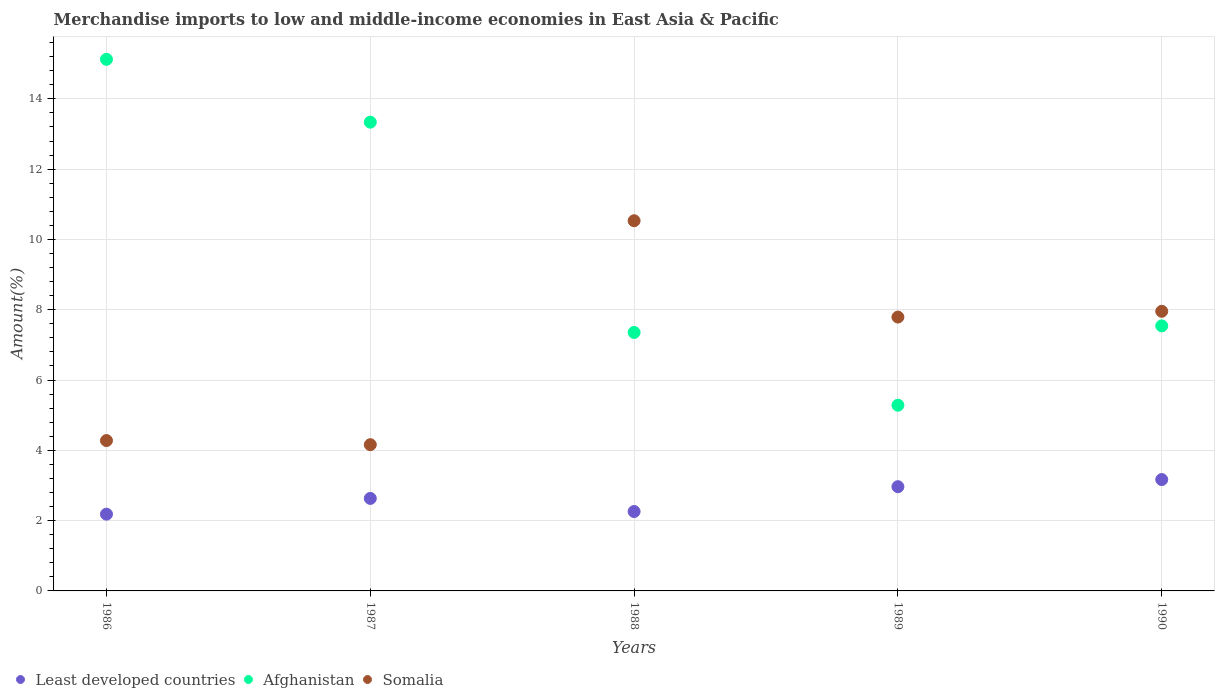Is the number of dotlines equal to the number of legend labels?
Provide a succinct answer. Yes. What is the percentage of amount earned from merchandise imports in Least developed countries in 1987?
Ensure brevity in your answer.  2.63. Across all years, what is the maximum percentage of amount earned from merchandise imports in Somalia?
Offer a very short reply. 10.53. Across all years, what is the minimum percentage of amount earned from merchandise imports in Afghanistan?
Offer a very short reply. 5.28. In which year was the percentage of amount earned from merchandise imports in Somalia maximum?
Give a very brief answer. 1988. What is the total percentage of amount earned from merchandise imports in Least developed countries in the graph?
Your response must be concise. 13.21. What is the difference between the percentage of amount earned from merchandise imports in Somalia in 1986 and that in 1988?
Your answer should be very brief. -6.25. What is the difference between the percentage of amount earned from merchandise imports in Least developed countries in 1986 and the percentage of amount earned from merchandise imports in Somalia in 1990?
Provide a short and direct response. -5.77. What is the average percentage of amount earned from merchandise imports in Somalia per year?
Provide a short and direct response. 6.94. In the year 1989, what is the difference between the percentage of amount earned from merchandise imports in Somalia and percentage of amount earned from merchandise imports in Afghanistan?
Provide a succinct answer. 2.51. What is the ratio of the percentage of amount earned from merchandise imports in Afghanistan in 1986 to that in 1987?
Make the answer very short. 1.13. Is the percentage of amount earned from merchandise imports in Least developed countries in 1989 less than that in 1990?
Provide a short and direct response. Yes. What is the difference between the highest and the second highest percentage of amount earned from merchandise imports in Least developed countries?
Ensure brevity in your answer.  0.2. What is the difference between the highest and the lowest percentage of amount earned from merchandise imports in Least developed countries?
Your answer should be very brief. 0.98. Is the sum of the percentage of amount earned from merchandise imports in Least developed countries in 1989 and 1990 greater than the maximum percentage of amount earned from merchandise imports in Somalia across all years?
Make the answer very short. No. Is it the case that in every year, the sum of the percentage of amount earned from merchandise imports in Least developed countries and percentage of amount earned from merchandise imports in Afghanistan  is greater than the percentage of amount earned from merchandise imports in Somalia?
Your answer should be compact. No. Is the percentage of amount earned from merchandise imports in Afghanistan strictly greater than the percentage of amount earned from merchandise imports in Somalia over the years?
Ensure brevity in your answer.  No. How many dotlines are there?
Your answer should be very brief. 3. What is the difference between two consecutive major ticks on the Y-axis?
Provide a succinct answer. 2. How are the legend labels stacked?
Provide a short and direct response. Horizontal. What is the title of the graph?
Give a very brief answer. Merchandise imports to low and middle-income economies in East Asia & Pacific. Does "Benin" appear as one of the legend labels in the graph?
Give a very brief answer. No. What is the label or title of the Y-axis?
Give a very brief answer. Amount(%). What is the Amount(%) in Least developed countries in 1986?
Make the answer very short. 2.18. What is the Amount(%) in Afghanistan in 1986?
Provide a short and direct response. 15.12. What is the Amount(%) of Somalia in 1986?
Your answer should be compact. 4.28. What is the Amount(%) of Least developed countries in 1987?
Your answer should be compact. 2.63. What is the Amount(%) of Afghanistan in 1987?
Provide a succinct answer. 13.34. What is the Amount(%) of Somalia in 1987?
Your answer should be very brief. 4.16. What is the Amount(%) of Least developed countries in 1988?
Keep it short and to the point. 2.26. What is the Amount(%) of Afghanistan in 1988?
Offer a terse response. 7.35. What is the Amount(%) of Somalia in 1988?
Your answer should be compact. 10.53. What is the Amount(%) of Least developed countries in 1989?
Make the answer very short. 2.97. What is the Amount(%) of Afghanistan in 1989?
Your answer should be very brief. 5.28. What is the Amount(%) in Somalia in 1989?
Give a very brief answer. 7.79. What is the Amount(%) of Least developed countries in 1990?
Your answer should be compact. 3.17. What is the Amount(%) of Afghanistan in 1990?
Provide a short and direct response. 7.54. What is the Amount(%) in Somalia in 1990?
Your response must be concise. 7.96. Across all years, what is the maximum Amount(%) in Least developed countries?
Your answer should be very brief. 3.17. Across all years, what is the maximum Amount(%) of Afghanistan?
Give a very brief answer. 15.12. Across all years, what is the maximum Amount(%) in Somalia?
Make the answer very short. 10.53. Across all years, what is the minimum Amount(%) of Least developed countries?
Make the answer very short. 2.18. Across all years, what is the minimum Amount(%) in Afghanistan?
Give a very brief answer. 5.28. Across all years, what is the minimum Amount(%) in Somalia?
Keep it short and to the point. 4.16. What is the total Amount(%) of Least developed countries in the graph?
Provide a short and direct response. 13.21. What is the total Amount(%) of Afghanistan in the graph?
Your answer should be very brief. 48.64. What is the total Amount(%) in Somalia in the graph?
Provide a short and direct response. 34.72. What is the difference between the Amount(%) of Least developed countries in 1986 and that in 1987?
Provide a short and direct response. -0.45. What is the difference between the Amount(%) in Afghanistan in 1986 and that in 1987?
Give a very brief answer. 1.79. What is the difference between the Amount(%) in Somalia in 1986 and that in 1987?
Offer a very short reply. 0.12. What is the difference between the Amount(%) of Least developed countries in 1986 and that in 1988?
Keep it short and to the point. -0.08. What is the difference between the Amount(%) of Afghanistan in 1986 and that in 1988?
Offer a terse response. 7.77. What is the difference between the Amount(%) in Somalia in 1986 and that in 1988?
Keep it short and to the point. -6.25. What is the difference between the Amount(%) of Least developed countries in 1986 and that in 1989?
Provide a succinct answer. -0.78. What is the difference between the Amount(%) in Afghanistan in 1986 and that in 1989?
Provide a short and direct response. 9.84. What is the difference between the Amount(%) in Somalia in 1986 and that in 1989?
Ensure brevity in your answer.  -3.51. What is the difference between the Amount(%) of Least developed countries in 1986 and that in 1990?
Your answer should be very brief. -0.98. What is the difference between the Amount(%) of Afghanistan in 1986 and that in 1990?
Ensure brevity in your answer.  7.58. What is the difference between the Amount(%) in Somalia in 1986 and that in 1990?
Keep it short and to the point. -3.68. What is the difference between the Amount(%) in Least developed countries in 1987 and that in 1988?
Provide a succinct answer. 0.37. What is the difference between the Amount(%) of Afghanistan in 1987 and that in 1988?
Provide a succinct answer. 5.98. What is the difference between the Amount(%) of Somalia in 1987 and that in 1988?
Your answer should be very brief. -6.37. What is the difference between the Amount(%) of Least developed countries in 1987 and that in 1989?
Offer a very short reply. -0.33. What is the difference between the Amount(%) of Afghanistan in 1987 and that in 1989?
Offer a terse response. 8.05. What is the difference between the Amount(%) of Somalia in 1987 and that in 1989?
Offer a terse response. -3.63. What is the difference between the Amount(%) in Least developed countries in 1987 and that in 1990?
Make the answer very short. -0.54. What is the difference between the Amount(%) of Afghanistan in 1987 and that in 1990?
Make the answer very short. 5.8. What is the difference between the Amount(%) of Somalia in 1987 and that in 1990?
Your answer should be compact. -3.79. What is the difference between the Amount(%) in Least developed countries in 1988 and that in 1989?
Give a very brief answer. -0.71. What is the difference between the Amount(%) of Afghanistan in 1988 and that in 1989?
Your answer should be very brief. 2.07. What is the difference between the Amount(%) of Somalia in 1988 and that in 1989?
Offer a very short reply. 2.74. What is the difference between the Amount(%) of Least developed countries in 1988 and that in 1990?
Offer a very short reply. -0.91. What is the difference between the Amount(%) in Afghanistan in 1988 and that in 1990?
Keep it short and to the point. -0.19. What is the difference between the Amount(%) of Somalia in 1988 and that in 1990?
Your answer should be compact. 2.58. What is the difference between the Amount(%) in Least developed countries in 1989 and that in 1990?
Provide a succinct answer. -0.2. What is the difference between the Amount(%) of Afghanistan in 1989 and that in 1990?
Offer a terse response. -2.26. What is the difference between the Amount(%) of Somalia in 1989 and that in 1990?
Provide a succinct answer. -0.16. What is the difference between the Amount(%) in Least developed countries in 1986 and the Amount(%) in Afghanistan in 1987?
Offer a terse response. -11.15. What is the difference between the Amount(%) in Least developed countries in 1986 and the Amount(%) in Somalia in 1987?
Keep it short and to the point. -1.98. What is the difference between the Amount(%) in Afghanistan in 1986 and the Amount(%) in Somalia in 1987?
Your response must be concise. 10.96. What is the difference between the Amount(%) in Least developed countries in 1986 and the Amount(%) in Afghanistan in 1988?
Offer a very short reply. -5.17. What is the difference between the Amount(%) of Least developed countries in 1986 and the Amount(%) of Somalia in 1988?
Provide a succinct answer. -8.35. What is the difference between the Amount(%) of Afghanistan in 1986 and the Amount(%) of Somalia in 1988?
Your response must be concise. 4.59. What is the difference between the Amount(%) of Least developed countries in 1986 and the Amount(%) of Afghanistan in 1989?
Your answer should be very brief. -3.1. What is the difference between the Amount(%) in Least developed countries in 1986 and the Amount(%) in Somalia in 1989?
Provide a short and direct response. -5.61. What is the difference between the Amount(%) in Afghanistan in 1986 and the Amount(%) in Somalia in 1989?
Your answer should be very brief. 7.33. What is the difference between the Amount(%) of Least developed countries in 1986 and the Amount(%) of Afghanistan in 1990?
Provide a short and direct response. -5.36. What is the difference between the Amount(%) of Least developed countries in 1986 and the Amount(%) of Somalia in 1990?
Ensure brevity in your answer.  -5.77. What is the difference between the Amount(%) of Afghanistan in 1986 and the Amount(%) of Somalia in 1990?
Your answer should be very brief. 7.17. What is the difference between the Amount(%) of Least developed countries in 1987 and the Amount(%) of Afghanistan in 1988?
Your response must be concise. -4.72. What is the difference between the Amount(%) of Least developed countries in 1987 and the Amount(%) of Somalia in 1988?
Your answer should be compact. -7.9. What is the difference between the Amount(%) of Afghanistan in 1987 and the Amount(%) of Somalia in 1988?
Keep it short and to the point. 2.8. What is the difference between the Amount(%) in Least developed countries in 1987 and the Amount(%) in Afghanistan in 1989?
Your answer should be very brief. -2.65. What is the difference between the Amount(%) in Least developed countries in 1987 and the Amount(%) in Somalia in 1989?
Make the answer very short. -5.16. What is the difference between the Amount(%) in Afghanistan in 1987 and the Amount(%) in Somalia in 1989?
Offer a very short reply. 5.55. What is the difference between the Amount(%) in Least developed countries in 1987 and the Amount(%) in Afghanistan in 1990?
Ensure brevity in your answer.  -4.91. What is the difference between the Amount(%) of Least developed countries in 1987 and the Amount(%) of Somalia in 1990?
Your answer should be compact. -5.32. What is the difference between the Amount(%) of Afghanistan in 1987 and the Amount(%) of Somalia in 1990?
Your answer should be very brief. 5.38. What is the difference between the Amount(%) in Least developed countries in 1988 and the Amount(%) in Afghanistan in 1989?
Keep it short and to the point. -3.02. What is the difference between the Amount(%) of Least developed countries in 1988 and the Amount(%) of Somalia in 1989?
Offer a very short reply. -5.53. What is the difference between the Amount(%) of Afghanistan in 1988 and the Amount(%) of Somalia in 1989?
Give a very brief answer. -0.44. What is the difference between the Amount(%) of Least developed countries in 1988 and the Amount(%) of Afghanistan in 1990?
Provide a short and direct response. -5.28. What is the difference between the Amount(%) of Least developed countries in 1988 and the Amount(%) of Somalia in 1990?
Your answer should be very brief. -5.7. What is the difference between the Amount(%) of Afghanistan in 1988 and the Amount(%) of Somalia in 1990?
Provide a short and direct response. -0.6. What is the difference between the Amount(%) in Least developed countries in 1989 and the Amount(%) in Afghanistan in 1990?
Offer a very short reply. -4.58. What is the difference between the Amount(%) in Least developed countries in 1989 and the Amount(%) in Somalia in 1990?
Your response must be concise. -4.99. What is the difference between the Amount(%) in Afghanistan in 1989 and the Amount(%) in Somalia in 1990?
Make the answer very short. -2.67. What is the average Amount(%) in Least developed countries per year?
Make the answer very short. 2.64. What is the average Amount(%) in Afghanistan per year?
Your answer should be very brief. 9.73. What is the average Amount(%) in Somalia per year?
Your response must be concise. 6.94. In the year 1986, what is the difference between the Amount(%) of Least developed countries and Amount(%) of Afghanistan?
Make the answer very short. -12.94. In the year 1986, what is the difference between the Amount(%) of Least developed countries and Amount(%) of Somalia?
Offer a terse response. -2.09. In the year 1986, what is the difference between the Amount(%) of Afghanistan and Amount(%) of Somalia?
Ensure brevity in your answer.  10.85. In the year 1987, what is the difference between the Amount(%) in Least developed countries and Amount(%) in Afghanistan?
Offer a very short reply. -10.7. In the year 1987, what is the difference between the Amount(%) in Least developed countries and Amount(%) in Somalia?
Your answer should be very brief. -1.53. In the year 1987, what is the difference between the Amount(%) in Afghanistan and Amount(%) in Somalia?
Give a very brief answer. 9.18. In the year 1988, what is the difference between the Amount(%) of Least developed countries and Amount(%) of Afghanistan?
Provide a succinct answer. -5.09. In the year 1988, what is the difference between the Amount(%) in Least developed countries and Amount(%) in Somalia?
Your answer should be very brief. -8.27. In the year 1988, what is the difference between the Amount(%) in Afghanistan and Amount(%) in Somalia?
Provide a short and direct response. -3.18. In the year 1989, what is the difference between the Amount(%) of Least developed countries and Amount(%) of Afghanistan?
Keep it short and to the point. -2.32. In the year 1989, what is the difference between the Amount(%) in Least developed countries and Amount(%) in Somalia?
Offer a very short reply. -4.83. In the year 1989, what is the difference between the Amount(%) of Afghanistan and Amount(%) of Somalia?
Your answer should be very brief. -2.51. In the year 1990, what is the difference between the Amount(%) in Least developed countries and Amount(%) in Afghanistan?
Give a very brief answer. -4.37. In the year 1990, what is the difference between the Amount(%) of Least developed countries and Amount(%) of Somalia?
Your response must be concise. -4.79. In the year 1990, what is the difference between the Amount(%) of Afghanistan and Amount(%) of Somalia?
Your answer should be very brief. -0.41. What is the ratio of the Amount(%) in Least developed countries in 1986 to that in 1987?
Offer a very short reply. 0.83. What is the ratio of the Amount(%) in Afghanistan in 1986 to that in 1987?
Keep it short and to the point. 1.13. What is the ratio of the Amount(%) of Somalia in 1986 to that in 1987?
Give a very brief answer. 1.03. What is the ratio of the Amount(%) in Least developed countries in 1986 to that in 1988?
Your answer should be compact. 0.97. What is the ratio of the Amount(%) in Afghanistan in 1986 to that in 1988?
Give a very brief answer. 2.06. What is the ratio of the Amount(%) in Somalia in 1986 to that in 1988?
Your response must be concise. 0.41. What is the ratio of the Amount(%) of Least developed countries in 1986 to that in 1989?
Keep it short and to the point. 0.74. What is the ratio of the Amount(%) of Afghanistan in 1986 to that in 1989?
Provide a succinct answer. 2.86. What is the ratio of the Amount(%) in Somalia in 1986 to that in 1989?
Make the answer very short. 0.55. What is the ratio of the Amount(%) of Least developed countries in 1986 to that in 1990?
Your response must be concise. 0.69. What is the ratio of the Amount(%) in Afghanistan in 1986 to that in 1990?
Your response must be concise. 2.01. What is the ratio of the Amount(%) of Somalia in 1986 to that in 1990?
Provide a succinct answer. 0.54. What is the ratio of the Amount(%) in Least developed countries in 1987 to that in 1988?
Make the answer very short. 1.17. What is the ratio of the Amount(%) of Afghanistan in 1987 to that in 1988?
Your answer should be compact. 1.81. What is the ratio of the Amount(%) in Somalia in 1987 to that in 1988?
Provide a short and direct response. 0.4. What is the ratio of the Amount(%) in Least developed countries in 1987 to that in 1989?
Give a very brief answer. 0.89. What is the ratio of the Amount(%) in Afghanistan in 1987 to that in 1989?
Provide a succinct answer. 2.52. What is the ratio of the Amount(%) of Somalia in 1987 to that in 1989?
Give a very brief answer. 0.53. What is the ratio of the Amount(%) of Least developed countries in 1987 to that in 1990?
Your answer should be very brief. 0.83. What is the ratio of the Amount(%) in Afghanistan in 1987 to that in 1990?
Give a very brief answer. 1.77. What is the ratio of the Amount(%) of Somalia in 1987 to that in 1990?
Your response must be concise. 0.52. What is the ratio of the Amount(%) in Least developed countries in 1988 to that in 1989?
Your response must be concise. 0.76. What is the ratio of the Amount(%) in Afghanistan in 1988 to that in 1989?
Provide a short and direct response. 1.39. What is the ratio of the Amount(%) of Somalia in 1988 to that in 1989?
Provide a short and direct response. 1.35. What is the ratio of the Amount(%) in Least developed countries in 1988 to that in 1990?
Offer a terse response. 0.71. What is the ratio of the Amount(%) of Afghanistan in 1988 to that in 1990?
Keep it short and to the point. 0.98. What is the ratio of the Amount(%) in Somalia in 1988 to that in 1990?
Your answer should be very brief. 1.32. What is the ratio of the Amount(%) of Least developed countries in 1989 to that in 1990?
Provide a short and direct response. 0.94. What is the ratio of the Amount(%) of Afghanistan in 1989 to that in 1990?
Give a very brief answer. 0.7. What is the ratio of the Amount(%) in Somalia in 1989 to that in 1990?
Keep it short and to the point. 0.98. What is the difference between the highest and the second highest Amount(%) of Least developed countries?
Provide a succinct answer. 0.2. What is the difference between the highest and the second highest Amount(%) in Afghanistan?
Keep it short and to the point. 1.79. What is the difference between the highest and the second highest Amount(%) in Somalia?
Make the answer very short. 2.58. What is the difference between the highest and the lowest Amount(%) of Least developed countries?
Provide a succinct answer. 0.98. What is the difference between the highest and the lowest Amount(%) in Afghanistan?
Make the answer very short. 9.84. What is the difference between the highest and the lowest Amount(%) of Somalia?
Offer a terse response. 6.37. 